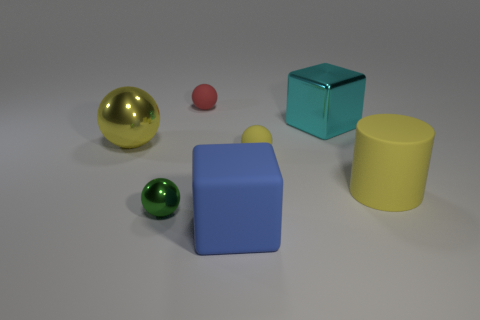Add 2 small cyan balls. How many objects exist? 9 Subtract all tiny green metallic balls. How many balls are left? 3 Subtract all green balls. How many balls are left? 3 Subtract 1 cylinders. How many cylinders are left? 0 Add 6 rubber things. How many rubber things are left? 10 Add 7 large cyan metallic blocks. How many large cyan metallic blocks exist? 8 Subtract 0 yellow blocks. How many objects are left? 7 Subtract all cubes. How many objects are left? 5 Subtract all brown spheres. Subtract all red cubes. How many spheres are left? 4 Subtract all gray blocks. How many cyan spheres are left? 0 